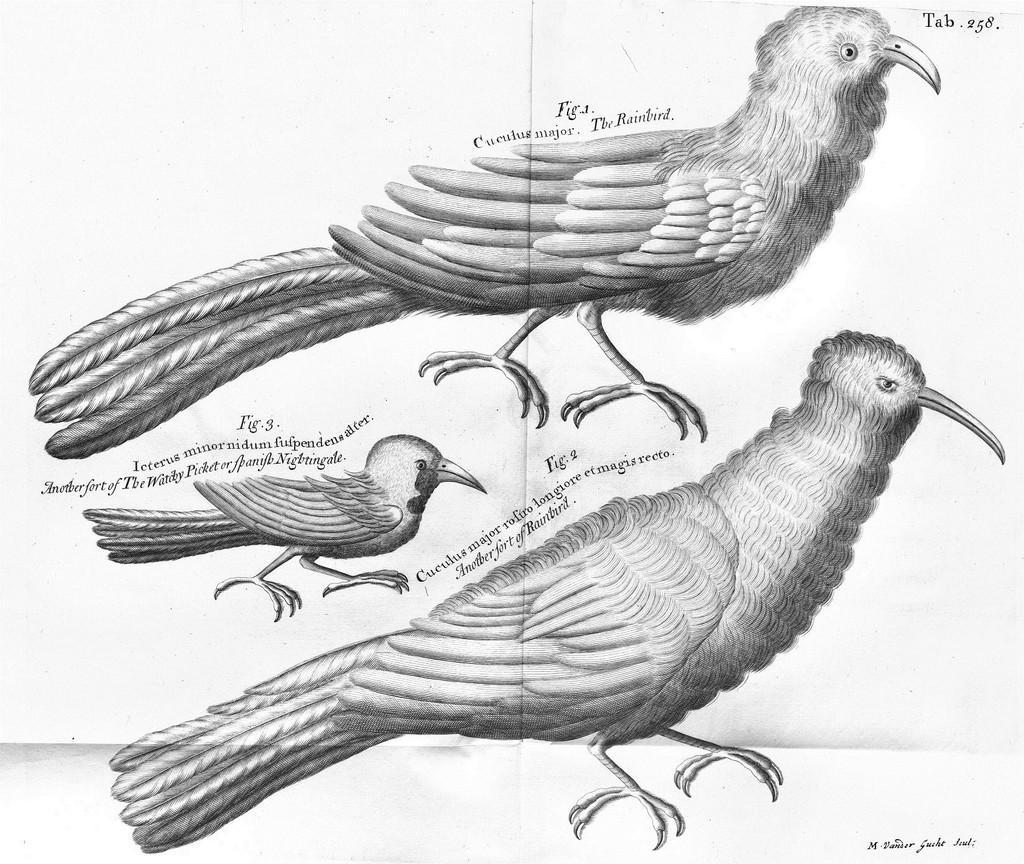In one or two sentences, can you explain what this image depicts? Here we can see drawing of birds labeled with numbers. Something written on this white surface. 